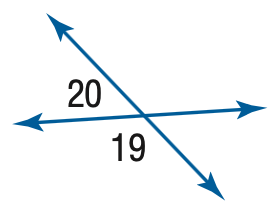Answer the mathemtical geometry problem and directly provide the correct option letter.
Question: m \angle 19 = 100 + 20 x, m \angle 20 = 20 x. Find the measure of \angle 20.
Choices: A: 20 B: 40 C: 60 D: 80 B 